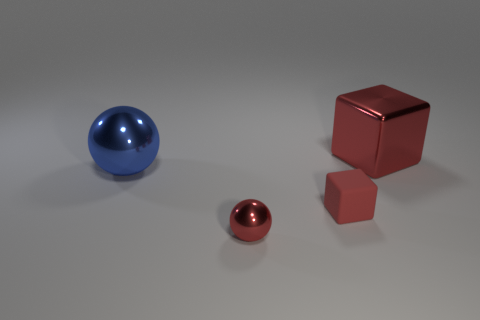What number of things are small blocks or small red shiny things?
Offer a very short reply. 2. The thing that is to the right of the small metallic ball and behind the red rubber thing has what shape?
Offer a very short reply. Cube. Does the object that is behind the large ball have the same material as the red sphere?
Provide a short and direct response. Yes. What number of objects are small blocks or tiny red cubes that are behind the small shiny object?
Your response must be concise. 1. The big block that is made of the same material as the large blue ball is what color?
Make the answer very short. Red. What number of blocks are made of the same material as the blue object?
Provide a succinct answer. 1. How many brown metal spheres are there?
Offer a terse response. 0. There is a block on the right side of the small block; is its color the same as the sphere to the left of the red ball?
Provide a short and direct response. No. There is a big metal cube; how many small red metal things are on the right side of it?
Offer a very short reply. 0. What is the material of the other block that is the same color as the rubber cube?
Offer a very short reply. Metal. 